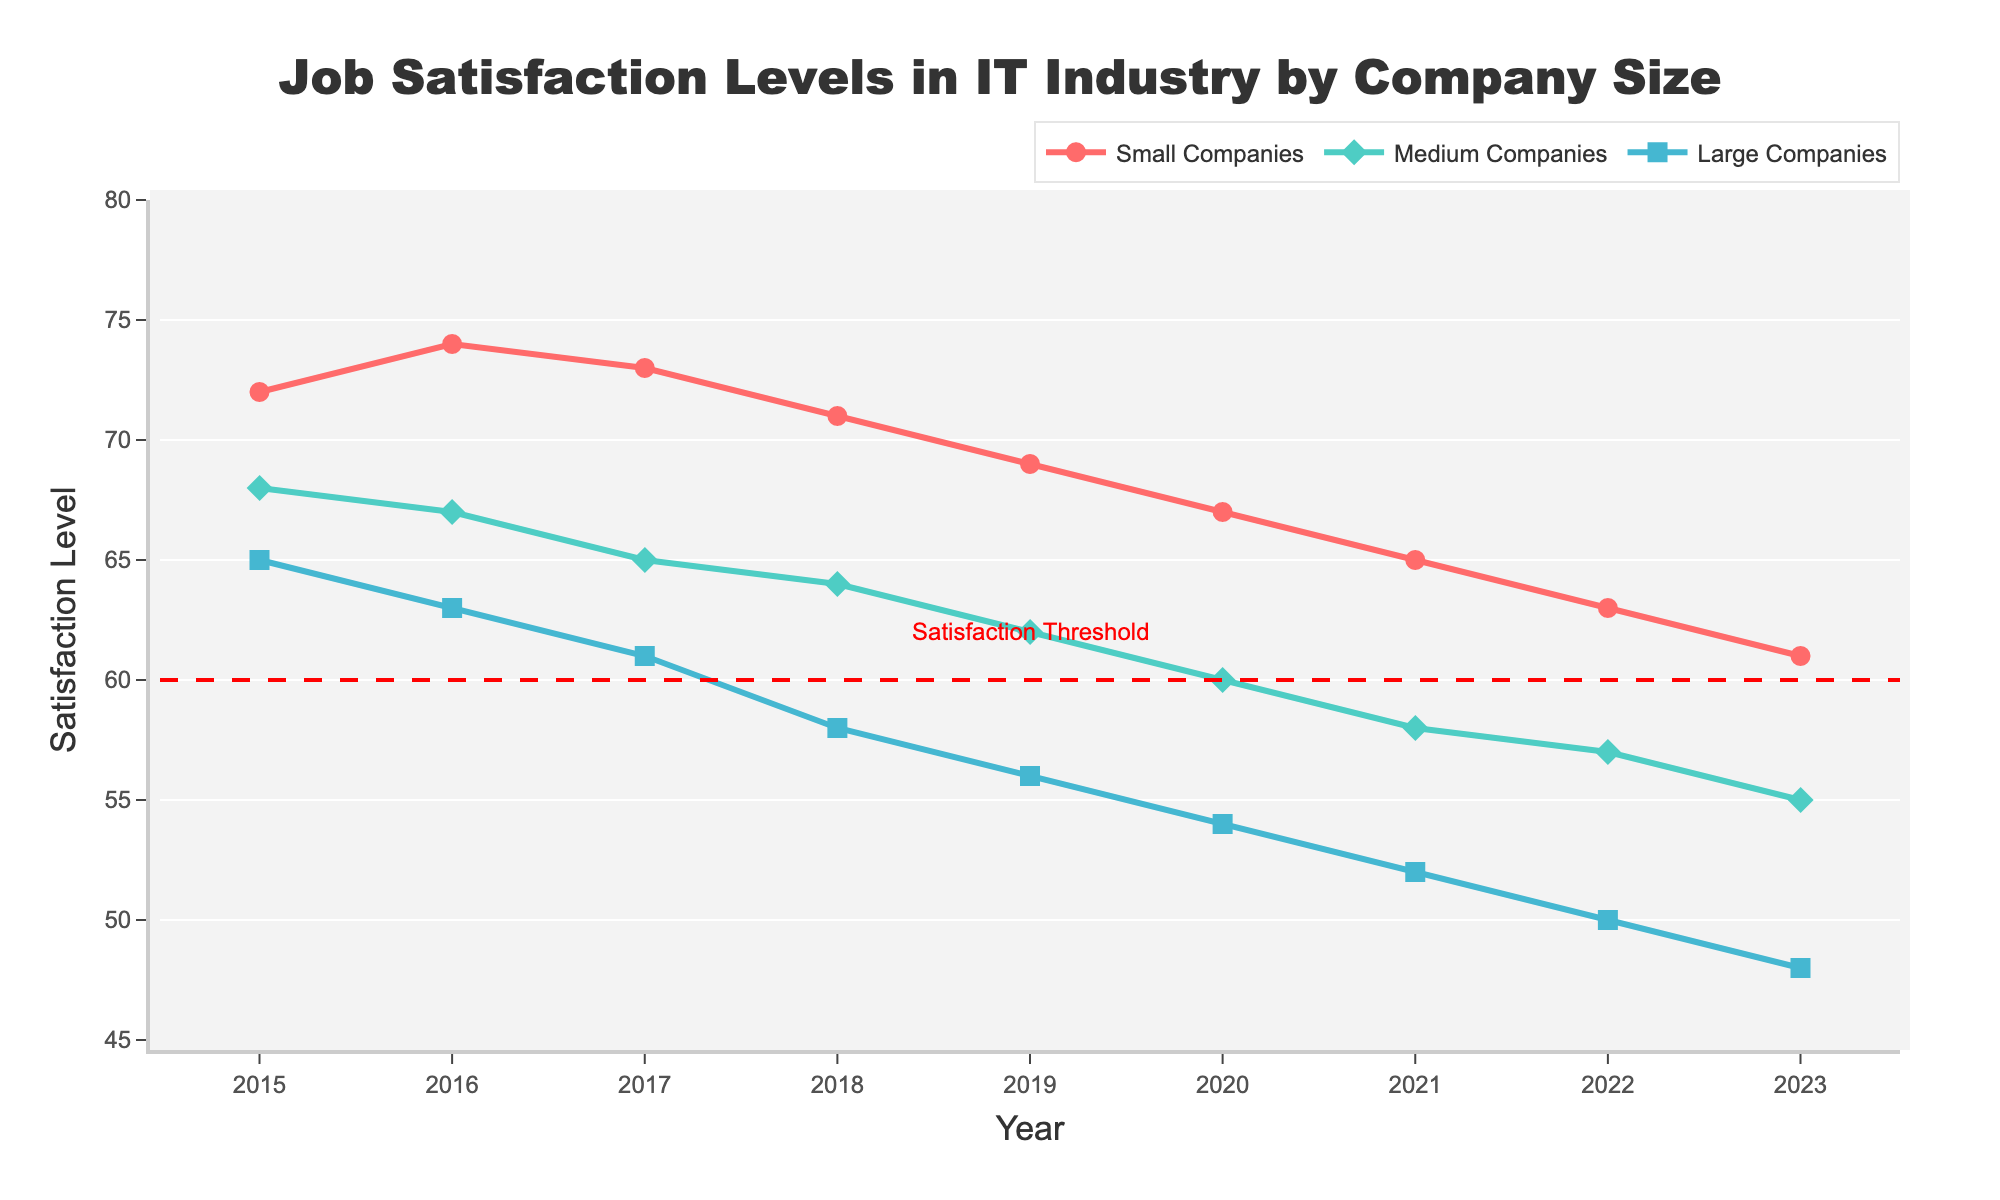What's the overall trend of job satisfaction levels in the IT industry from 2015 to 2023? The overall trend shows a decline in job satisfaction levels across all company sizes. This can be observed as the lines for all three categories (Small, Medium, and Large Companies) consistently decrease over the years.
Answer: Declining Between which years did large companies experience the steepest drop in job satisfaction levels? To identify the steepest drop, we need to look at the year-on-year differences for large companies. The largest drop is between 2017 and 2018, where the satisfaction level dropped from 61 to 58, a difference of 3 points.
Answer: 2017-2018 How does the job satisfaction level for small companies in 2023 compare to the satisfaction threshold marked on the plot? The satisfaction threshold is marked at 60, with a dashed red line. In 2023, the job satisfaction level for small companies is 61, which is slightly above this threshold.
Answer: Slightly above What is the average job satisfaction level for medium-sized companies over the entire period? The job satisfaction data points for medium-sized companies from 2015 to 2023 are 68, 67, 65, 64, 62, 60, 58, 57, and 55. Summing them gives 556. Dividing by the 9 years, the average is 556 / 9 ≈ 61.78.
Answer: 61.78 Which company size had the highest job satisfaction level in 2016? To determine this, look at the data points for 2016: Small Companies had a level of 74, Medium Companies had 67, and Large Companies had 63. Small Companies had the highest level.
Answer: Small Companies By how many points did job satisfaction for small companies decrease from 2015 to 2023? The job satisfaction level for small companies was 72 in 2015 and 61 in 2023. The decrease is 72 - 61 = 11 points.
Answer: 11 Which company size maintained a job satisfaction level above the satisfaction threshold for the longest period? The satisfaction threshold is at 60. Small Companies stayed above this threshold from 2015 to 2022, while Medium Companies dropped below in 2021, and Large Companies were consistently below since 2017. Therefore, Small Companies maintained it the longest.
Answer: Small Companies During which year did medium-sized companies have the lowest job satisfaction level? To identify the year, we look for the minimum value for medium companies. The lowest level for medium-sized companies is 55 in 2023.
Answer: 2023 How much higher was the job satisfaction level for small companies compared to large companies in 2019? In 2019, small companies had a job satisfaction level of 69, while large companies had 56. The difference is 69 - 56 = 13 points.
Answer: 13 Based on the plot, predict the job satisfaction level for large companies in 2024 if the downward trend continues at the same rate as from 2022 to 2023. From 2022 to 2023, large companies' job satisfaction level decreased from 50 to 48 by 2 points. If the trend continues, in 2024, it would be 48 - 2 = 46.
Answer: 46 